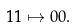Convert formula to latex. <formula><loc_0><loc_0><loc_500><loc_500>1 1 \mapsto 0 0 .</formula> 